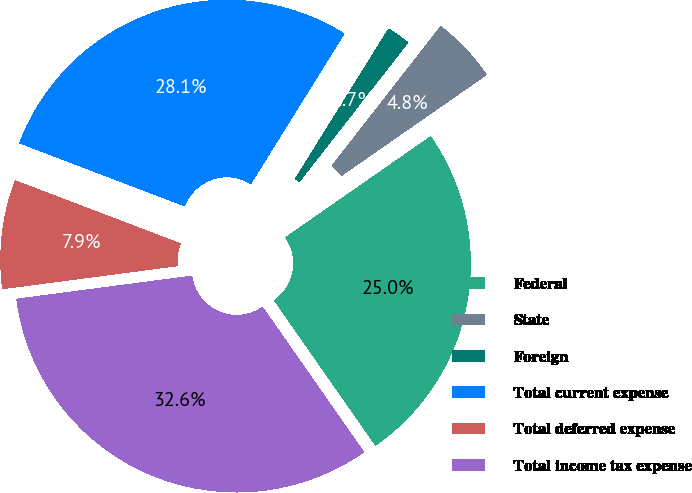Convert chart to OTSL. <chart><loc_0><loc_0><loc_500><loc_500><pie_chart><fcel>Federal<fcel>State<fcel>Foreign<fcel>Total current expense<fcel>Total deferred expense<fcel>Total income tax expense<nl><fcel>24.97%<fcel>4.78%<fcel>1.69%<fcel>28.06%<fcel>7.88%<fcel>32.62%<nl></chart> 